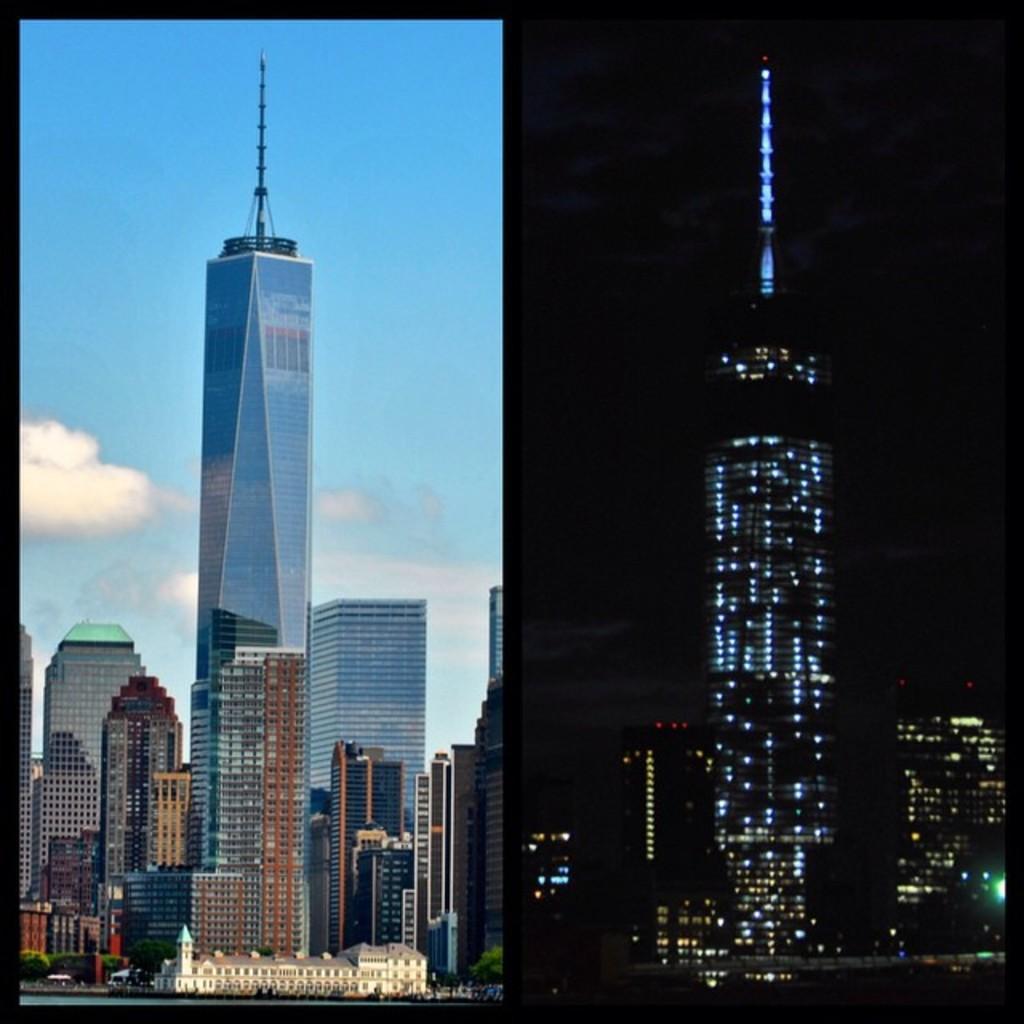How would you summarize this image in a sentence or two? In this image we can see the buildings, lake and the sky with clouds on the left side, there are buildings and lights on the right side of the image. 